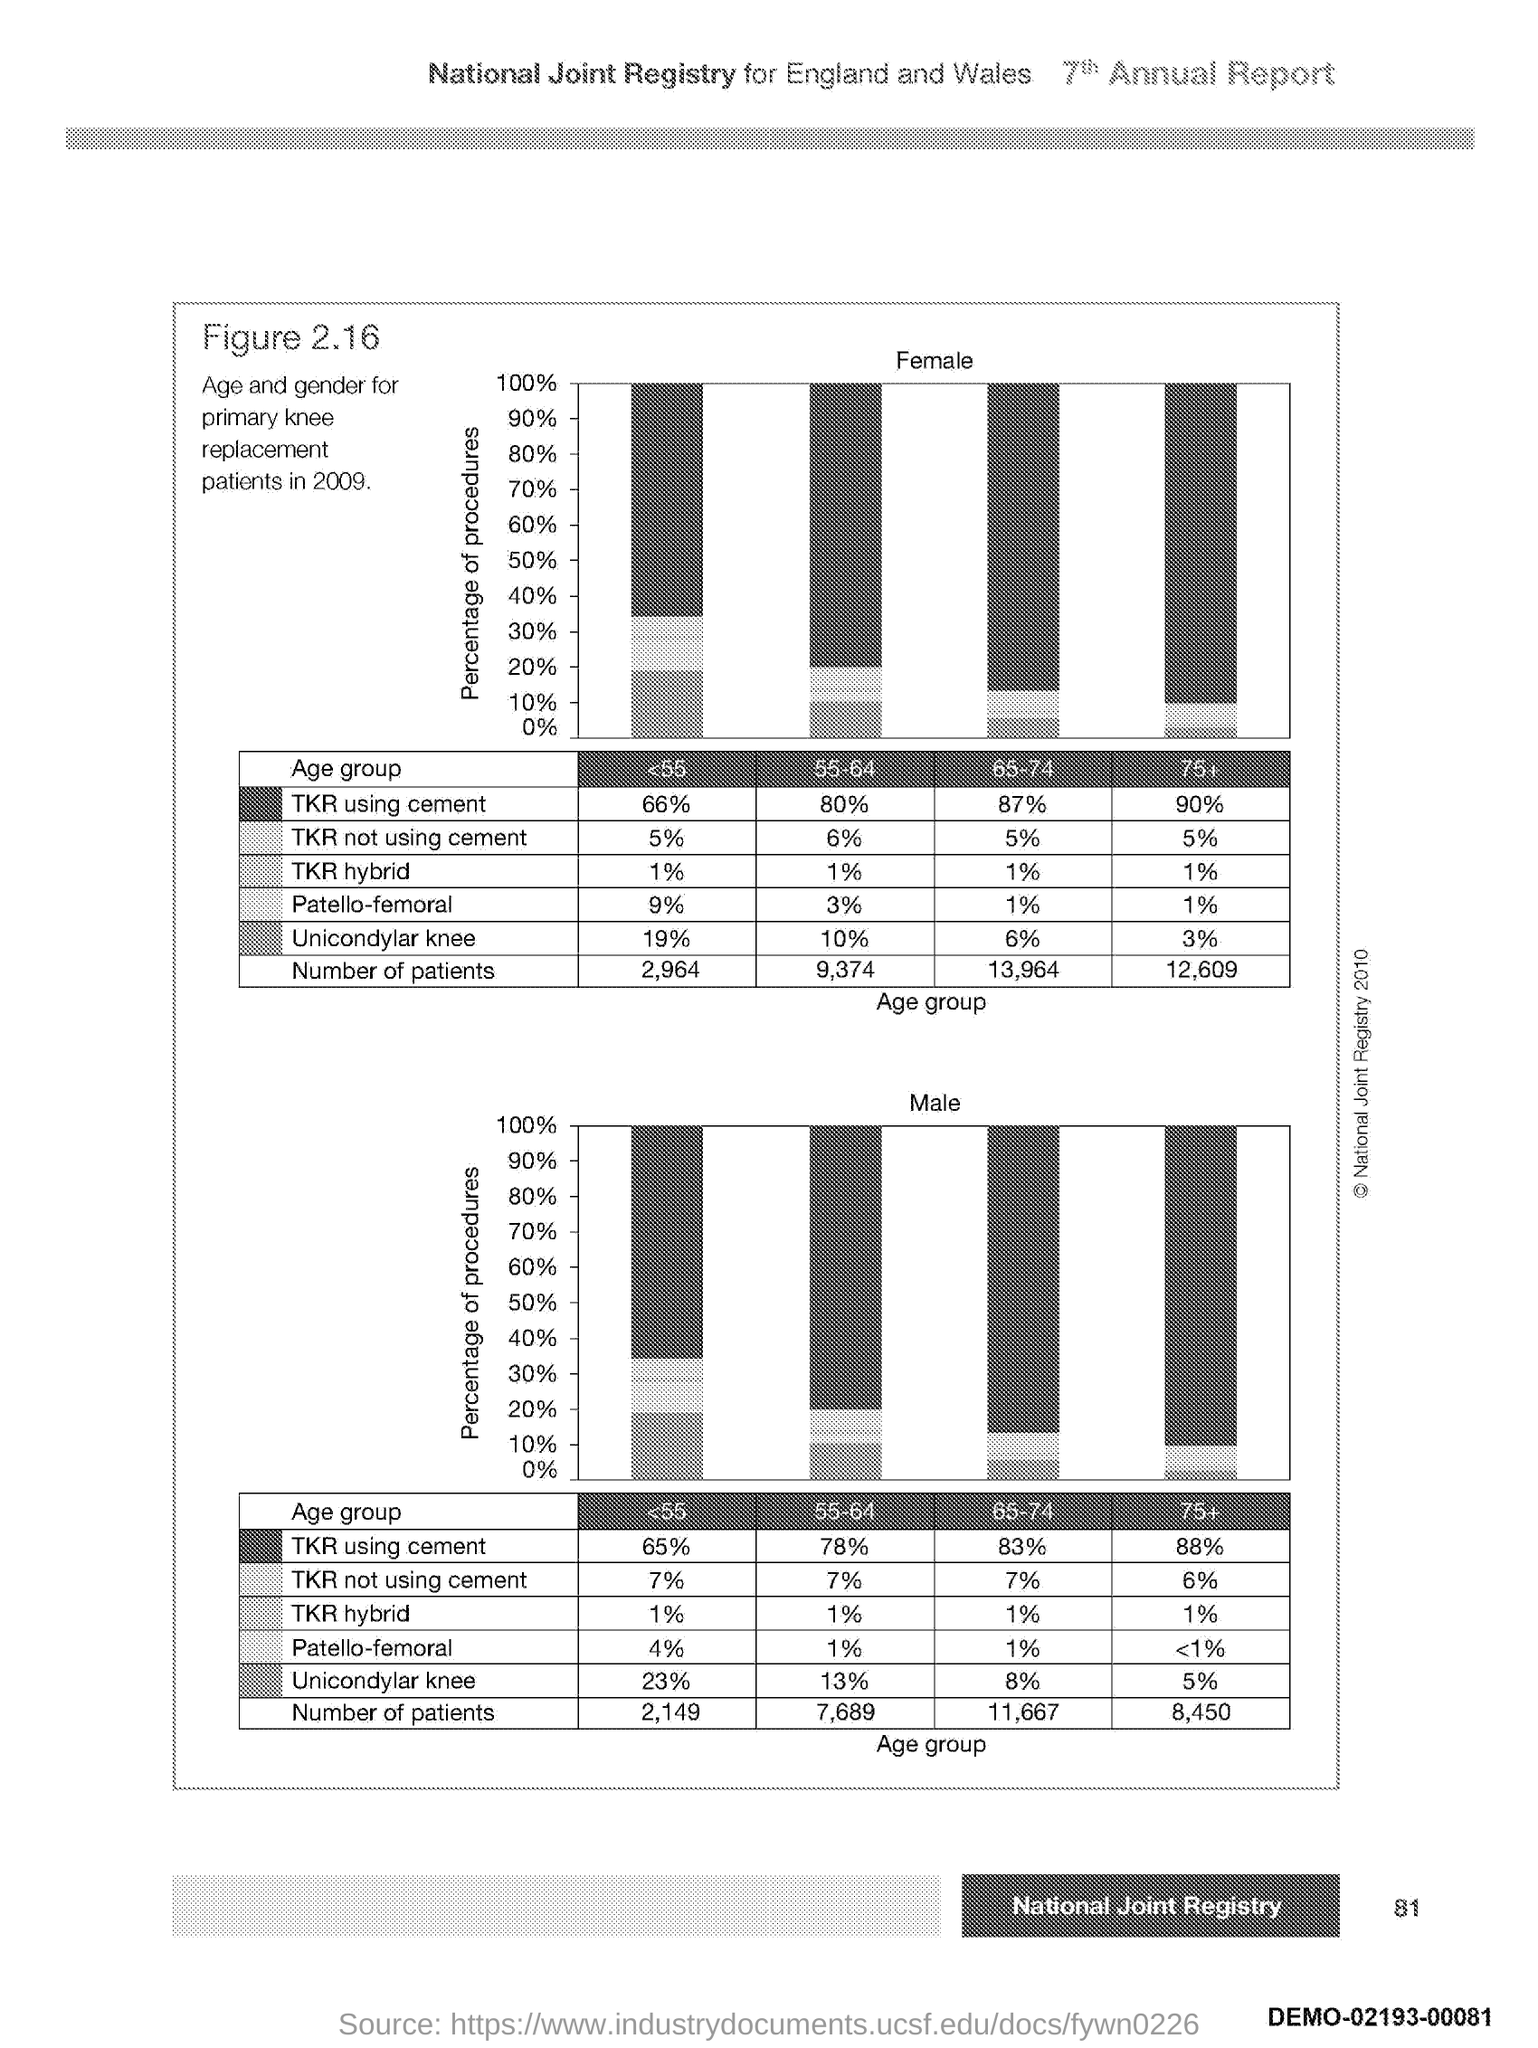Identify some key points in this picture. The first graph plots the percentage of procedures as the value plotted on the y-axis. The second graph plots the percentage of procedures as the value plotted on the y-axis. 